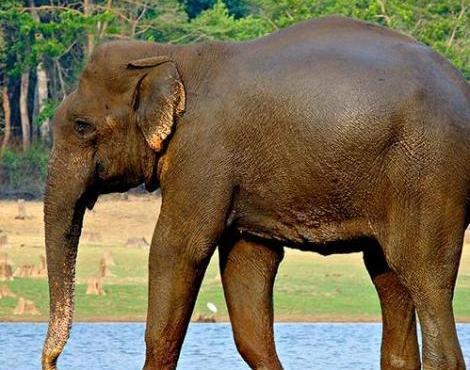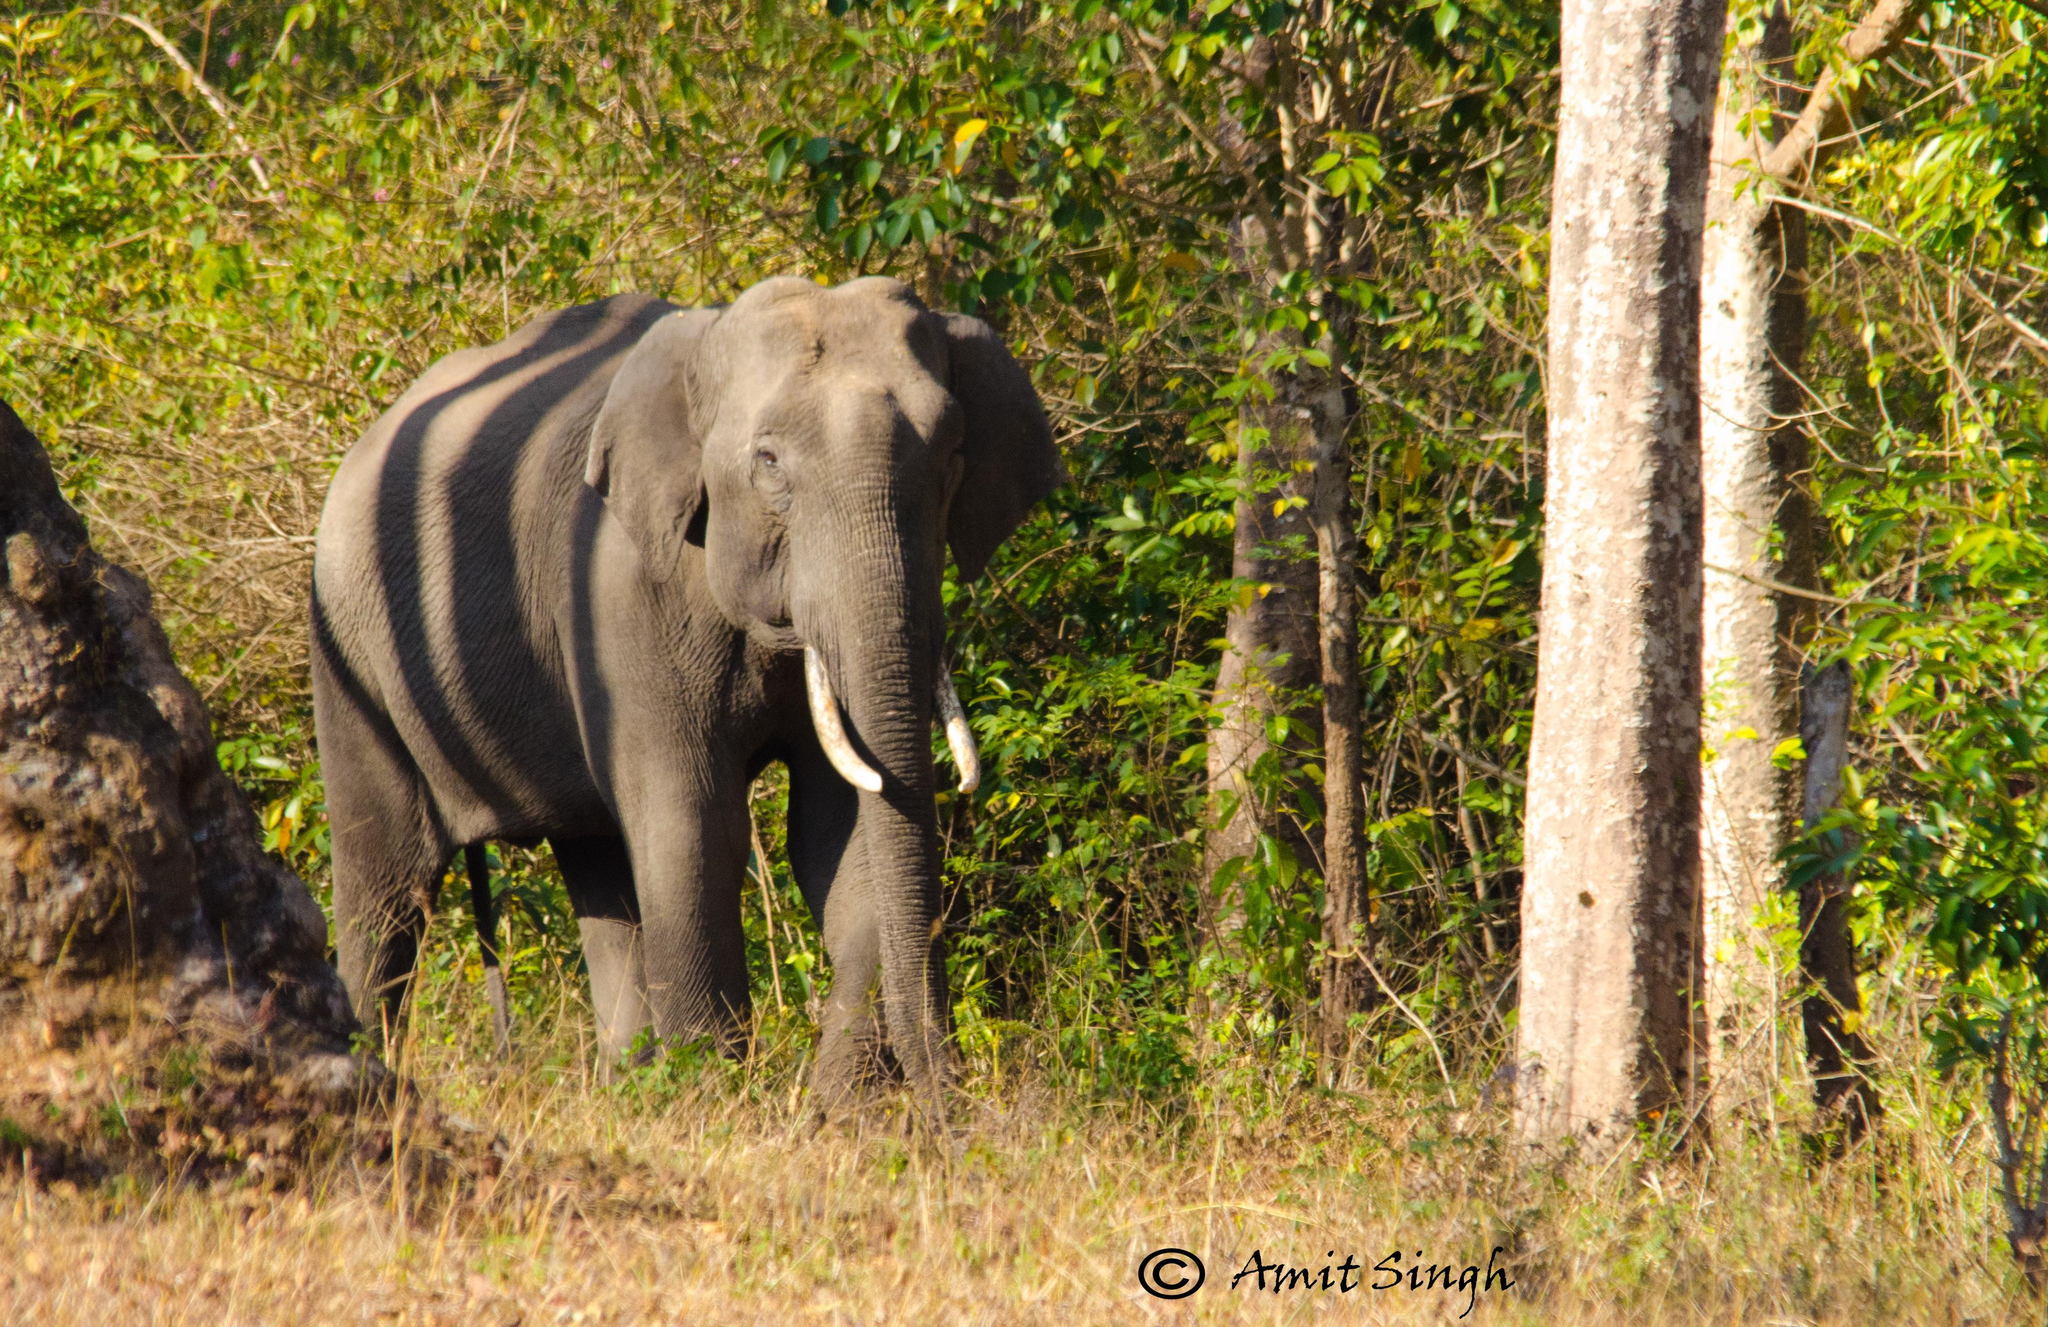The first image is the image on the left, the second image is the image on the right. Examine the images to the left and right. Is the description "The right image contains exactly one elephant that is walking towards the right." accurate? Answer yes or no. Yes. The first image is the image on the left, the second image is the image on the right. Examine the images to the left and right. Is the description "Both elephants have white tusks." accurate? Answer yes or no. No. 